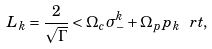<formula> <loc_0><loc_0><loc_500><loc_500>L _ { k } = \frac { 2 } { \sqrt { \Gamma } } < \Omega _ { c } \sigma _ { - } ^ { k } + \Omega _ { p } p _ { k } \ r t ,</formula> 